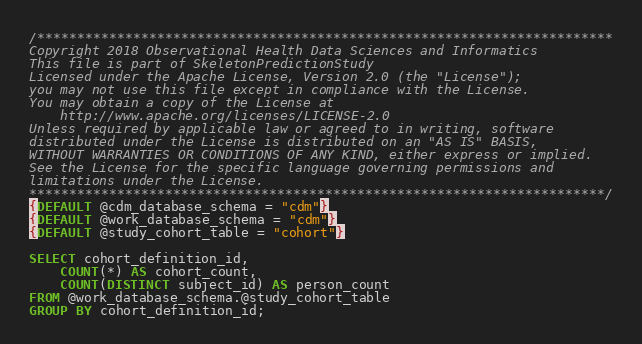Convert code to text. <code><loc_0><loc_0><loc_500><loc_500><_SQL_>/************************************************************************
Copyright 2018 Observational Health Data Sciences and Informatics
This file is part of SkeletonPredictionStudy
Licensed under the Apache License, Version 2.0 (the "License");
you may not use this file except in compliance with the License.
You may obtain a copy of the License at
    http://www.apache.org/licenses/LICENSE-2.0
Unless required by applicable law or agreed to in writing, software
distributed under the License is distributed on an "AS IS" BASIS,
WITHOUT WARRANTIES OR CONDITIONS OF ANY KIND, either express or implied.
See the License for the specific language governing permissions and
limitations under the License.
************************************************************************/
{DEFAULT @cdm_database_schema = "cdm"}
{DEFAULT @work_database_schema = "cdm"}
{DEFAULT @study_cohort_table = "cohort"}

SELECT cohort_definition_id,
	COUNT(*) AS cohort_count,
	COUNT(DISTINCT subject_id) AS person_count
FROM @work_database_schema.@study_cohort_table
GROUP BY cohort_definition_id;
</code> 